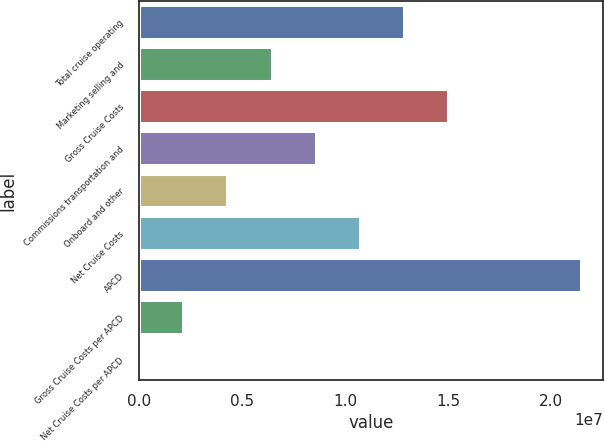Convert chart. <chart><loc_0><loc_0><loc_500><loc_500><bar_chart><fcel>Total cruise operating<fcel>Marketing selling and<fcel>Gross Cruise Costs<fcel>Commissions transportation and<fcel>Onboard and other<fcel>Net Cruise Costs<fcel>APCD<fcel>Gross Cruise Costs per APCD<fcel>Net Cruise Costs per APCD<nl><fcel>1.28636e+07<fcel>6.43186e+06<fcel>1.50075e+07<fcel>8.57578e+06<fcel>4.28794e+06<fcel>1.07197e+07<fcel>2.14393e+07<fcel>2.14402e+06<fcel>106.57<nl></chart> 